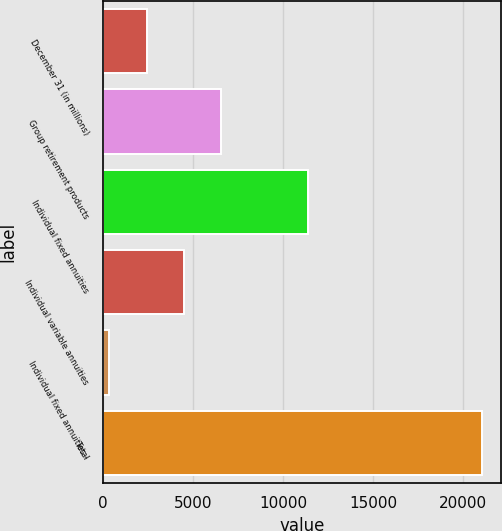<chart> <loc_0><loc_0><loc_500><loc_500><bar_chart><fcel>December 31 (in millions)<fcel>Group retirement products<fcel>Individual fixed annuities<fcel>Individual variable annuities<fcel>Individual fixed annuities -<fcel>Total<nl><fcel>2421.4<fcel>6564.2<fcel>11384<fcel>4492.8<fcel>350<fcel>21064<nl></chart> 